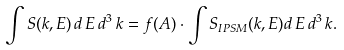<formula> <loc_0><loc_0><loc_500><loc_500>\int S ( { k } , E ) \, d \, E \, d ^ { 3 } \, { k } = f ( A ) \cdot \int S _ { I P S M } ( { k } , E ) d \, E \, d ^ { 3 } \, { k } .</formula> 